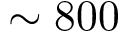<formula> <loc_0><loc_0><loc_500><loc_500>\sim 8 0 0</formula> 